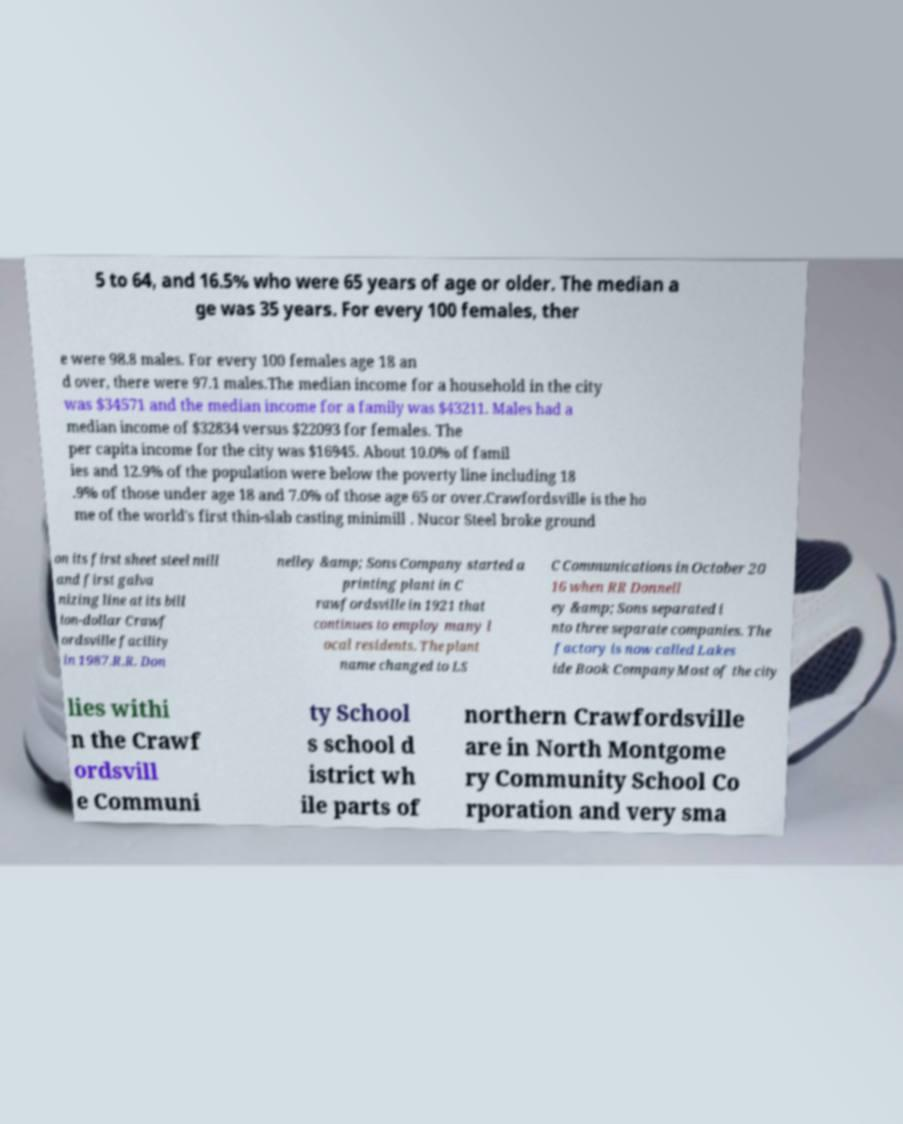Could you assist in decoding the text presented in this image and type it out clearly? 5 to 64, and 16.5% who were 65 years of age or older. The median a ge was 35 years. For every 100 females, ther e were 98.8 males. For every 100 females age 18 an d over, there were 97.1 males.The median income for a household in the city was $34571 and the median income for a family was $43211. Males had a median income of $32834 versus $22093 for females. The per capita income for the city was $16945. About 10.0% of famil ies and 12.9% of the population were below the poverty line including 18 .9% of those under age 18 and 7.0% of those age 65 or over.Crawfordsville is the ho me of the world's first thin-slab casting minimill . Nucor Steel broke ground on its first sheet steel mill and first galva nizing line at its bill ion-dollar Crawf ordsville facility in 1987.R.R. Don nelley &amp; Sons Company started a printing plant in C rawfordsville in 1921 that continues to employ many l ocal residents. The plant name changed to LS C Communications in October 20 16 when RR Donnell ey &amp; Sons separated i nto three separate companies. The factory is now called Lakes ide Book CompanyMost of the city lies withi n the Crawf ordsvill e Communi ty School s school d istrict wh ile parts of northern Crawfordsville are in North Montgome ry Community School Co rporation and very sma 